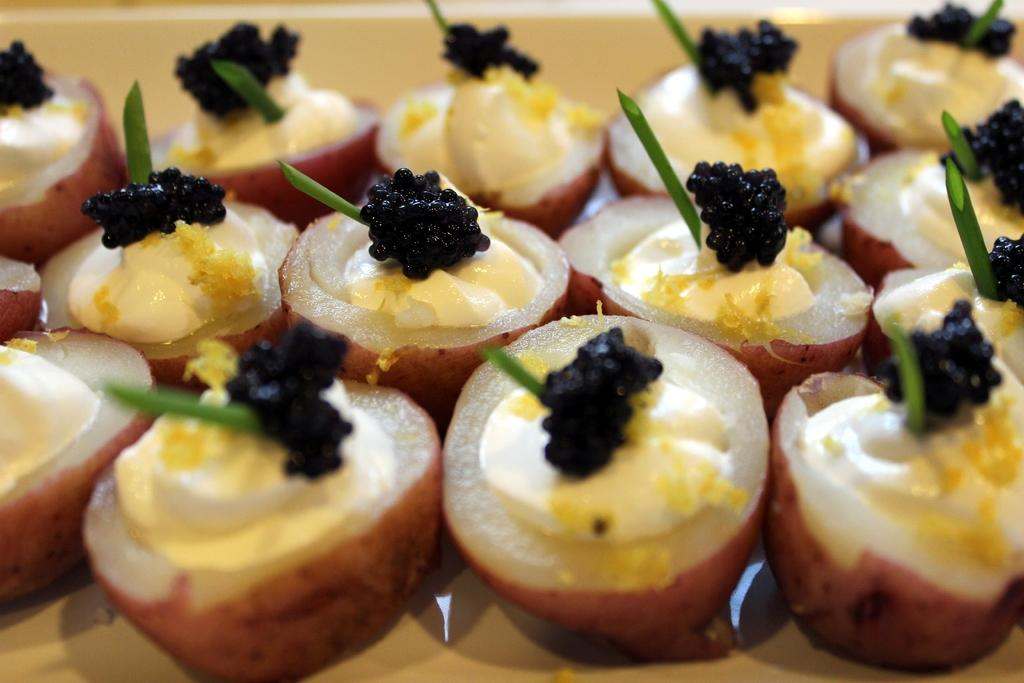What type of food is present on the surface in the image? There are sweets on a surface in the image. What is the appearance of the sweets? The sweets have cream on them. Can you describe the object with a green stick on the sweets? There is a black color thing with a green stick on the sweets. What type of pickle is present on the sweets in the image? There is no pickle present on the sweets in the image. What type of agreement is being made between the sweets in the image? There is no agreement being made between the sweets in the image. 